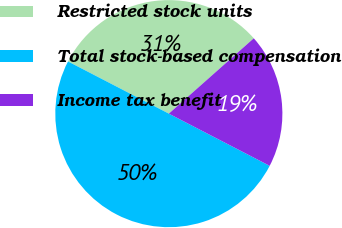Convert chart to OTSL. <chart><loc_0><loc_0><loc_500><loc_500><pie_chart><fcel>Restricted stock units<fcel>Total stock-based compensation<fcel>Income tax benefit<nl><fcel>30.85%<fcel>50.0%<fcel>19.15%<nl></chart> 